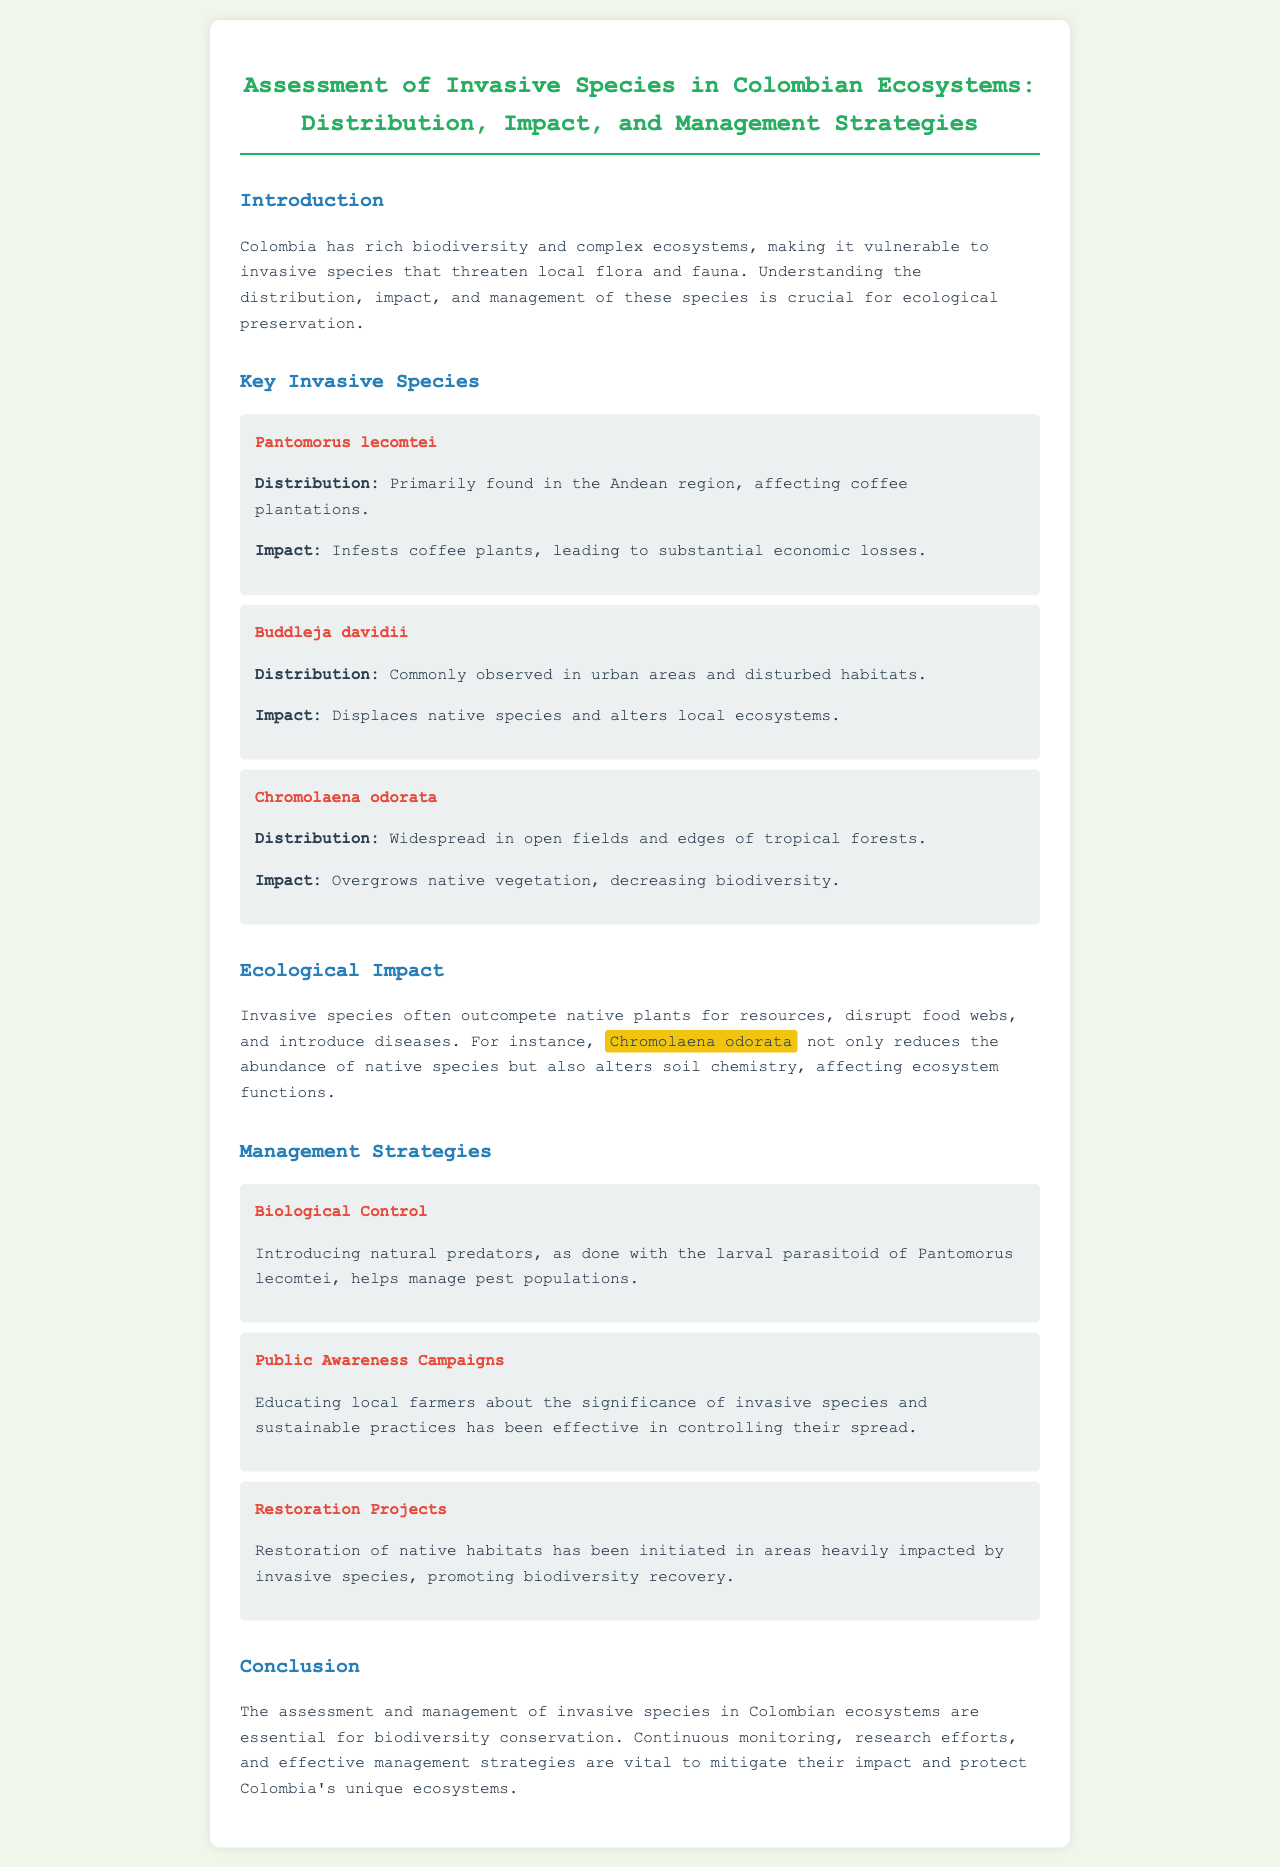What is the title of the report? The title of the report is given at the top of the document, summarizing the main topic.
Answer: Assessment of Invasive Species in Colombian Ecosystems: Distribution, Impact, and Management Strategies What region is Pantomorus lecomtei primarily found in? The report states the specific region where this invasive species is mostly located.
Answer: Andean region What type of control is mentioned as a management strategy? The document lists several strategies and specifies that natural predators can be used as a part of managing these species.
Answer: Biological Control What impact does Buddleja davidii have on ecosystems? The report details how this species affects local flora and the consequences for biodiversity.
Answer: Displaces native species and alters local ecosystems Which invasive species is highlighted for reducing native species abundance? The report emphasizes this species for its significant effect on local biodiversity and soil chemistry.
Answer: Chromolaena odorata How many management strategies are listed in the document? The document outlines various strategies aimed at managing the impact of invasive species.
Answer: Three What is the primary goal of the public awareness campaigns? The report explains this strategy's focus regarding the control of invasive species.
Answer: Educating local farmers What is the overall conclusion regarding invasive species management? The conclusion synthesizes the importance of ongoing efforts related to this ecological issue.
Answer: Essential for biodiversity conservation 